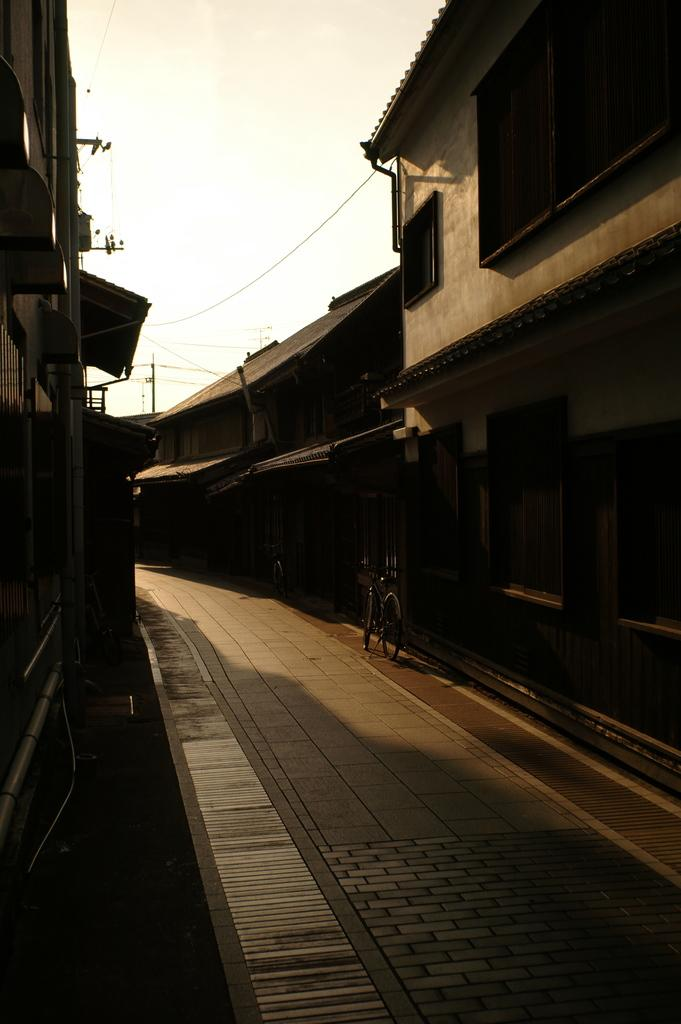What is on the road in the image? There is a bicycle on the road in the image. What can be seen beside the road in the image? There are buildings beside the road in the image. What is visible at the top of the image? The sky is visible at the top of the image. What else is present in the image? Wires are present in the image. How many dinosaurs can be seen grazing on the grass in the image? There are no dinosaurs present in the image; it features a bicycle on the road, buildings, sky, and wires. What type of goat is standing near the bicycle in the image? There is no goat present in the image; it only features a bicycle on the road, buildings, sky, and wires. 